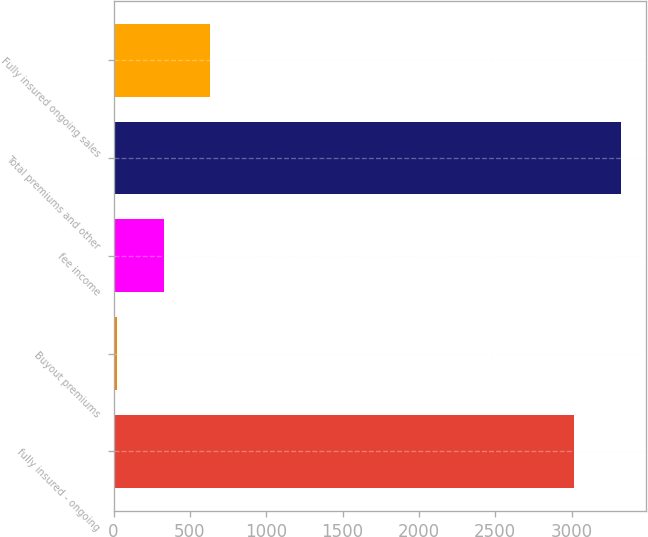<chart> <loc_0><loc_0><loc_500><loc_500><bar_chart><fcel>fully insured - ongoing<fcel>Buyout premiums<fcel>fee income<fcel>Total premiums and other<fcel>Fully insured ongoing sales<nl><fcel>3014<fcel>20<fcel>327.5<fcel>3321.5<fcel>635<nl></chart> 